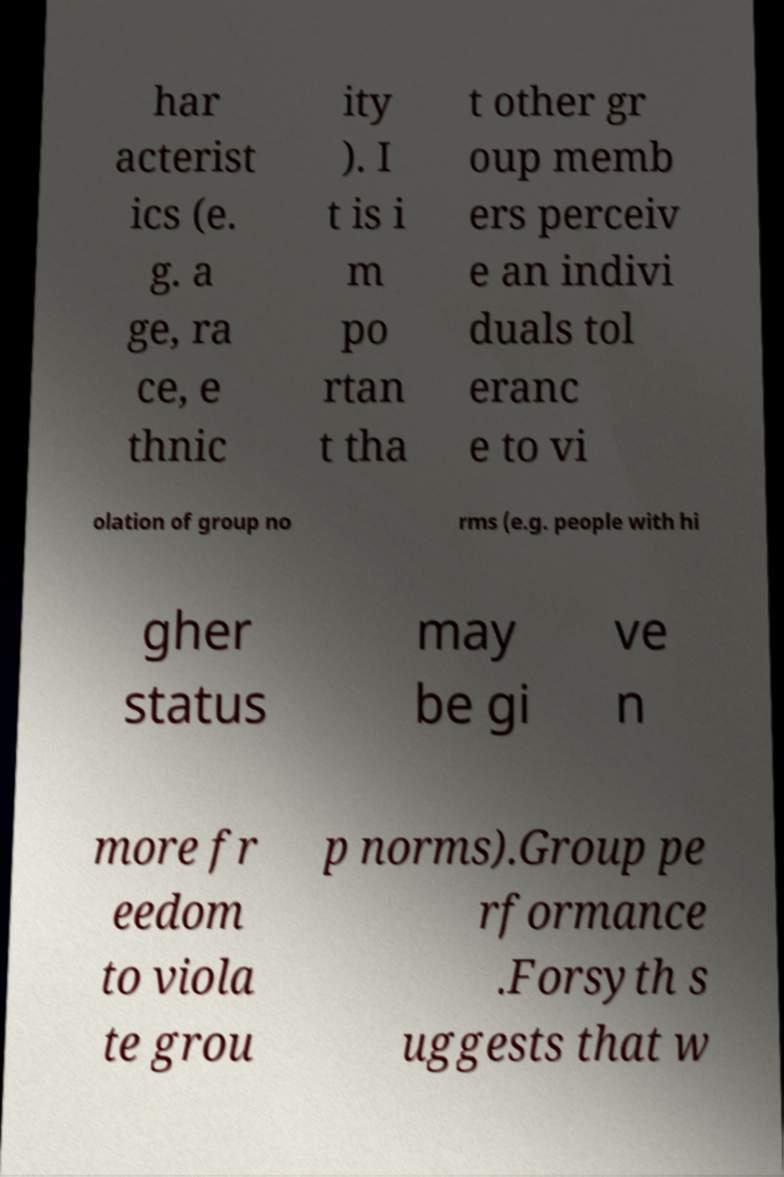Could you assist in decoding the text presented in this image and type it out clearly? har acterist ics (e. g. a ge, ra ce, e thnic ity ). I t is i m po rtan t tha t other gr oup memb ers perceiv e an indivi duals tol eranc e to vi olation of group no rms (e.g. people with hi gher status may be gi ve n more fr eedom to viola te grou p norms).Group pe rformance .Forsyth s uggests that w 